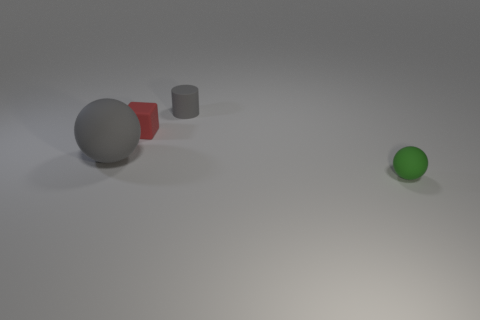Are there any other things that are the same size as the gray matte ball?
Offer a very short reply. No. What number of large matte spheres are in front of the green matte sphere?
Provide a succinct answer. 0. There is a ball that is behind the object in front of the ball behind the small matte sphere; what size is it?
Offer a very short reply. Large. Is the shape of the small gray thing the same as the gray object in front of the small rubber block?
Provide a succinct answer. No. What size is the gray sphere that is made of the same material as the cylinder?
Make the answer very short. Large. Is there anything else that is the same color as the small matte ball?
Your answer should be very brief. No. There is a gray cylinder that is on the right side of the ball to the left of the small matte object that is in front of the gray ball; what is it made of?
Offer a terse response. Rubber. How many matte things are either small red objects or big brown cubes?
Ensure brevity in your answer.  1. Do the tiny cylinder and the large ball have the same color?
Offer a terse response. Yes. Is there any other thing that is made of the same material as the large sphere?
Ensure brevity in your answer.  Yes. 